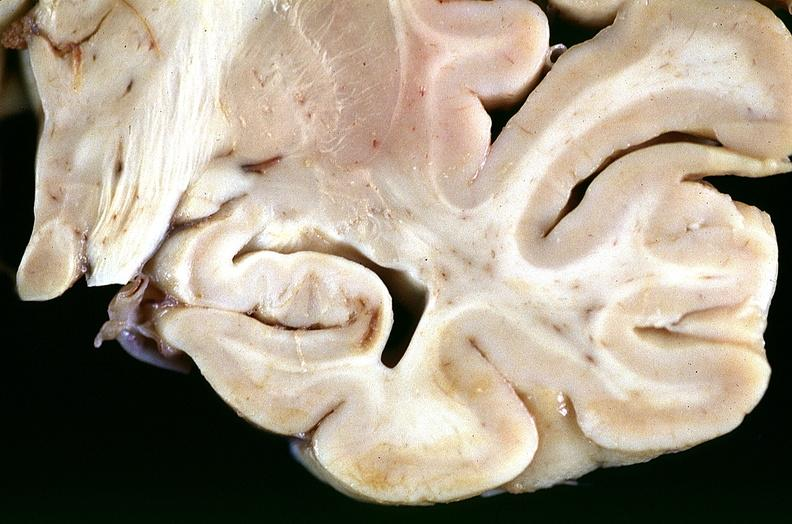s spina bifida present?
Answer the question using a single word or phrase. No 